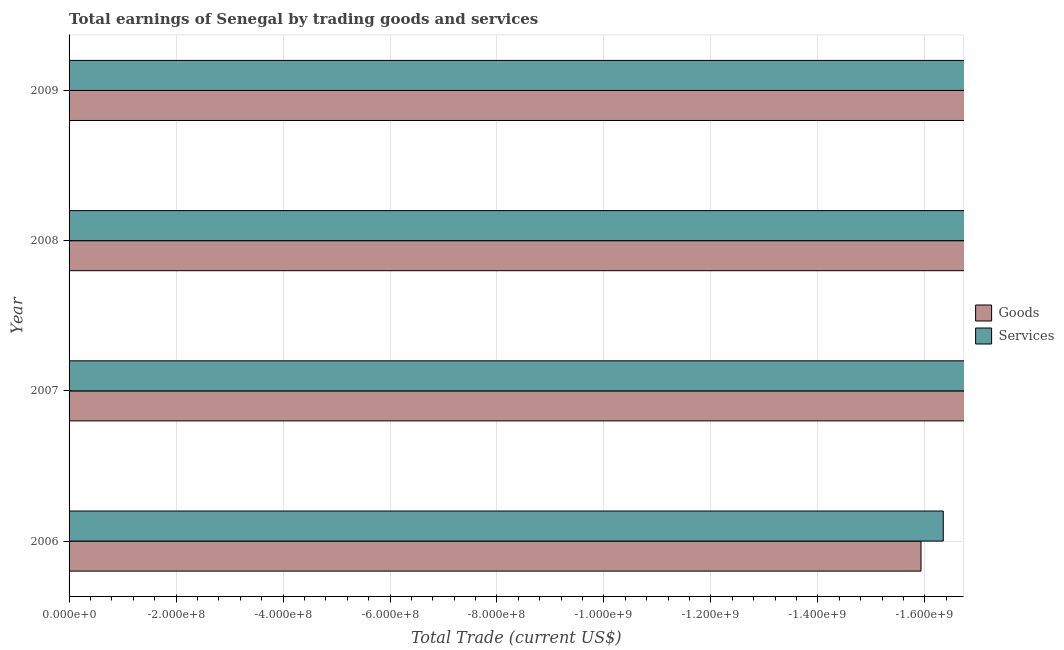How many different coloured bars are there?
Your response must be concise. 0. Are the number of bars per tick equal to the number of legend labels?
Give a very brief answer. No. Are the number of bars on each tick of the Y-axis equal?
Your answer should be very brief. Yes. How many bars are there on the 3rd tick from the top?
Provide a short and direct response. 0. What is the label of the 4th group of bars from the top?
Give a very brief answer. 2006. What is the amount earned by trading services in 2006?
Make the answer very short. 0. Across all years, what is the minimum amount earned by trading services?
Make the answer very short. 0. What is the total amount earned by trading services in the graph?
Give a very brief answer. 0. What is the difference between the amount earned by trading services in 2008 and the amount earned by trading goods in 2007?
Provide a short and direct response. 0. What is the average amount earned by trading goods per year?
Ensure brevity in your answer.  0. In how many years, is the amount earned by trading goods greater than -1160000000 US$?
Ensure brevity in your answer.  0. How many bars are there?
Provide a short and direct response. 0. Are all the bars in the graph horizontal?
Provide a succinct answer. Yes. What is the difference between two consecutive major ticks on the X-axis?
Give a very brief answer. 2.00e+08. Are the values on the major ticks of X-axis written in scientific E-notation?
Give a very brief answer. Yes. How many legend labels are there?
Offer a very short reply. 2. What is the title of the graph?
Offer a very short reply. Total earnings of Senegal by trading goods and services. What is the label or title of the X-axis?
Your response must be concise. Total Trade (current US$). What is the label or title of the Y-axis?
Provide a short and direct response. Year. What is the Total Trade (current US$) of Goods in 2006?
Keep it short and to the point. 0. What is the Total Trade (current US$) of Services in 2007?
Provide a succinct answer. 0. What is the Total Trade (current US$) in Goods in 2008?
Your response must be concise. 0. What is the Total Trade (current US$) in Services in 2008?
Offer a terse response. 0. What is the Total Trade (current US$) in Goods in 2009?
Provide a short and direct response. 0. What is the Total Trade (current US$) in Services in 2009?
Offer a terse response. 0. What is the average Total Trade (current US$) in Services per year?
Make the answer very short. 0. 